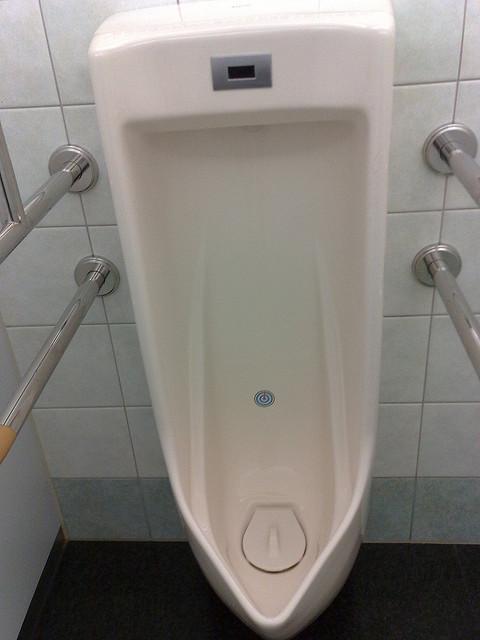Is this a conventional toilet?
Answer briefly. No. What room is this located in?
Be succinct. Bathroom. What color is the urinal?
Answer briefly. White. 